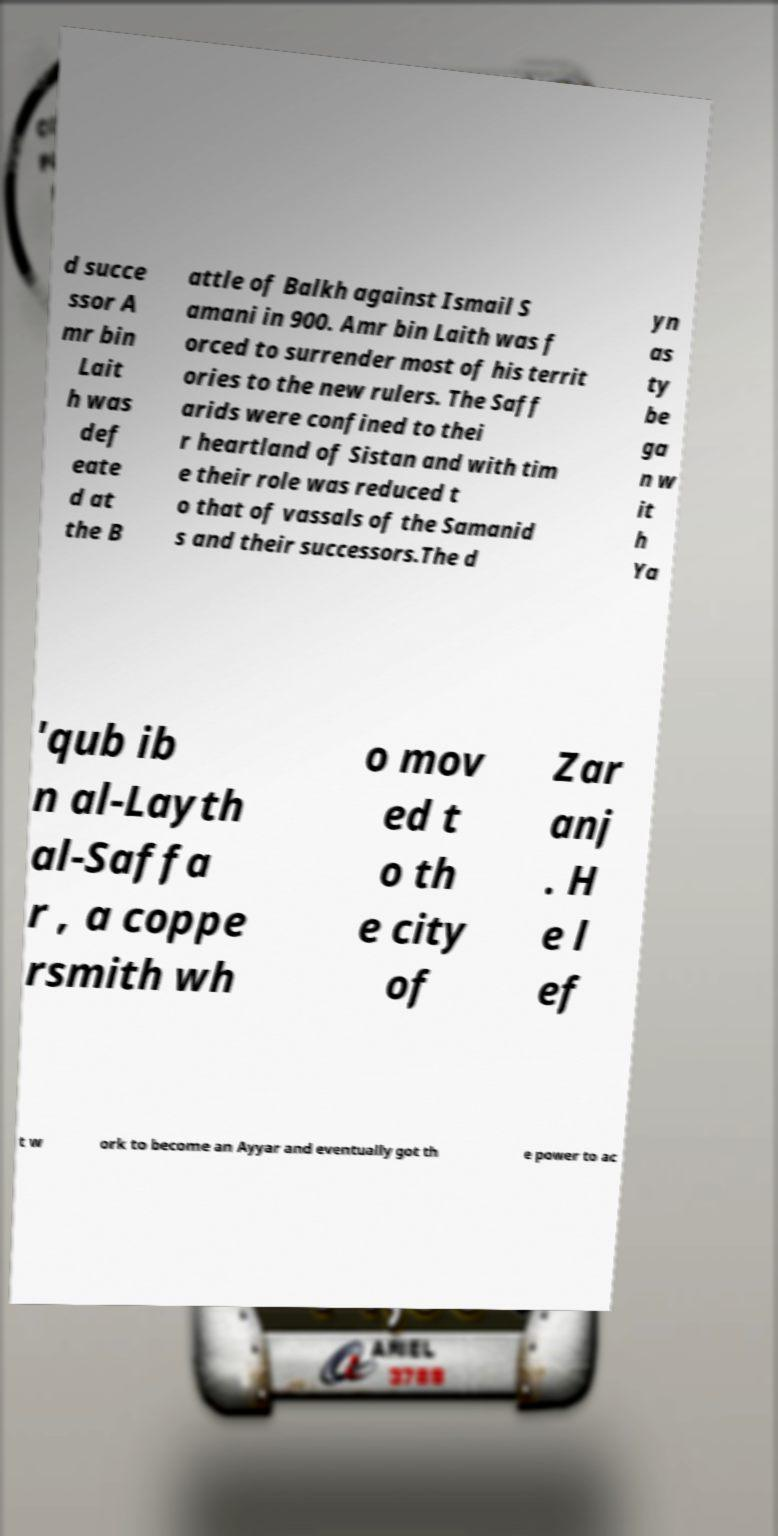Can you read and provide the text displayed in the image?This photo seems to have some interesting text. Can you extract and type it out for me? d succe ssor A mr bin Lait h was def eate d at the B attle of Balkh against Ismail S amani in 900. Amr bin Laith was f orced to surrender most of his territ ories to the new rulers. The Saff arids were confined to thei r heartland of Sistan and with tim e their role was reduced t o that of vassals of the Samanid s and their successors.The d yn as ty be ga n w it h Ya 'qub ib n al-Layth al-Saffa r , a coppe rsmith wh o mov ed t o th e city of Zar anj . H e l ef t w ork to become an Ayyar and eventually got th e power to ac 